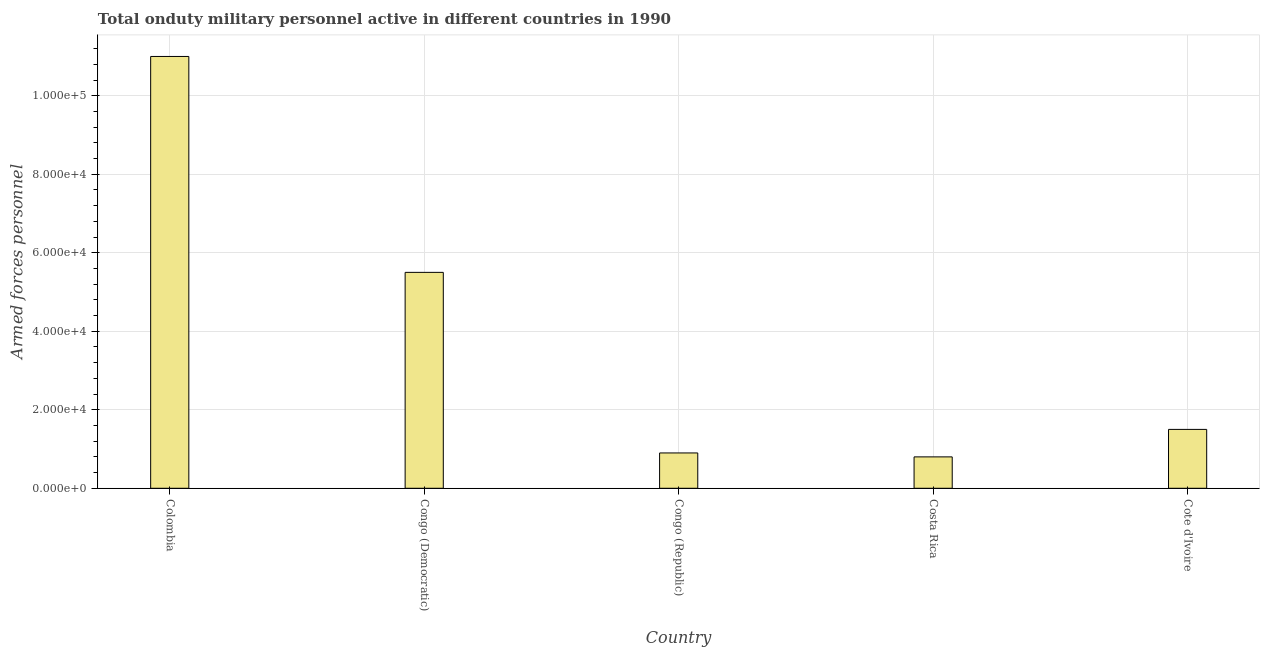Does the graph contain any zero values?
Provide a succinct answer. No. What is the title of the graph?
Make the answer very short. Total onduty military personnel active in different countries in 1990. What is the label or title of the X-axis?
Your answer should be very brief. Country. What is the label or title of the Y-axis?
Your answer should be very brief. Armed forces personnel. What is the number of armed forces personnel in Cote d'Ivoire?
Your answer should be very brief. 1.50e+04. Across all countries, what is the maximum number of armed forces personnel?
Offer a terse response. 1.10e+05. Across all countries, what is the minimum number of armed forces personnel?
Offer a very short reply. 8000. What is the sum of the number of armed forces personnel?
Provide a short and direct response. 1.97e+05. What is the difference between the number of armed forces personnel in Colombia and Costa Rica?
Provide a short and direct response. 1.02e+05. What is the average number of armed forces personnel per country?
Give a very brief answer. 3.94e+04. What is the median number of armed forces personnel?
Your answer should be very brief. 1.50e+04. In how many countries, is the number of armed forces personnel greater than 24000 ?
Keep it short and to the point. 2. What is the ratio of the number of armed forces personnel in Colombia to that in Costa Rica?
Ensure brevity in your answer.  13.75. Is the number of armed forces personnel in Colombia less than that in Congo (Democratic)?
Your answer should be compact. No. What is the difference between the highest and the second highest number of armed forces personnel?
Make the answer very short. 5.50e+04. Is the sum of the number of armed forces personnel in Congo (Democratic) and Congo (Republic) greater than the maximum number of armed forces personnel across all countries?
Offer a very short reply. No. What is the difference between the highest and the lowest number of armed forces personnel?
Your answer should be compact. 1.02e+05. What is the difference between two consecutive major ticks on the Y-axis?
Give a very brief answer. 2.00e+04. What is the Armed forces personnel of Congo (Democratic)?
Offer a terse response. 5.50e+04. What is the Armed forces personnel of Congo (Republic)?
Your response must be concise. 9000. What is the Armed forces personnel in Costa Rica?
Provide a succinct answer. 8000. What is the Armed forces personnel of Cote d'Ivoire?
Offer a very short reply. 1.50e+04. What is the difference between the Armed forces personnel in Colombia and Congo (Democratic)?
Keep it short and to the point. 5.50e+04. What is the difference between the Armed forces personnel in Colombia and Congo (Republic)?
Provide a succinct answer. 1.01e+05. What is the difference between the Armed forces personnel in Colombia and Costa Rica?
Ensure brevity in your answer.  1.02e+05. What is the difference between the Armed forces personnel in Colombia and Cote d'Ivoire?
Provide a succinct answer. 9.50e+04. What is the difference between the Armed forces personnel in Congo (Democratic) and Congo (Republic)?
Your response must be concise. 4.60e+04. What is the difference between the Armed forces personnel in Congo (Democratic) and Costa Rica?
Offer a very short reply. 4.70e+04. What is the difference between the Armed forces personnel in Congo (Republic) and Cote d'Ivoire?
Offer a very short reply. -6000. What is the difference between the Armed forces personnel in Costa Rica and Cote d'Ivoire?
Your answer should be compact. -7000. What is the ratio of the Armed forces personnel in Colombia to that in Congo (Republic)?
Keep it short and to the point. 12.22. What is the ratio of the Armed forces personnel in Colombia to that in Costa Rica?
Offer a terse response. 13.75. What is the ratio of the Armed forces personnel in Colombia to that in Cote d'Ivoire?
Ensure brevity in your answer.  7.33. What is the ratio of the Armed forces personnel in Congo (Democratic) to that in Congo (Republic)?
Offer a terse response. 6.11. What is the ratio of the Armed forces personnel in Congo (Democratic) to that in Costa Rica?
Provide a short and direct response. 6.88. What is the ratio of the Armed forces personnel in Congo (Democratic) to that in Cote d'Ivoire?
Offer a very short reply. 3.67. What is the ratio of the Armed forces personnel in Congo (Republic) to that in Costa Rica?
Your answer should be very brief. 1.12. What is the ratio of the Armed forces personnel in Congo (Republic) to that in Cote d'Ivoire?
Ensure brevity in your answer.  0.6. What is the ratio of the Armed forces personnel in Costa Rica to that in Cote d'Ivoire?
Your answer should be very brief. 0.53. 